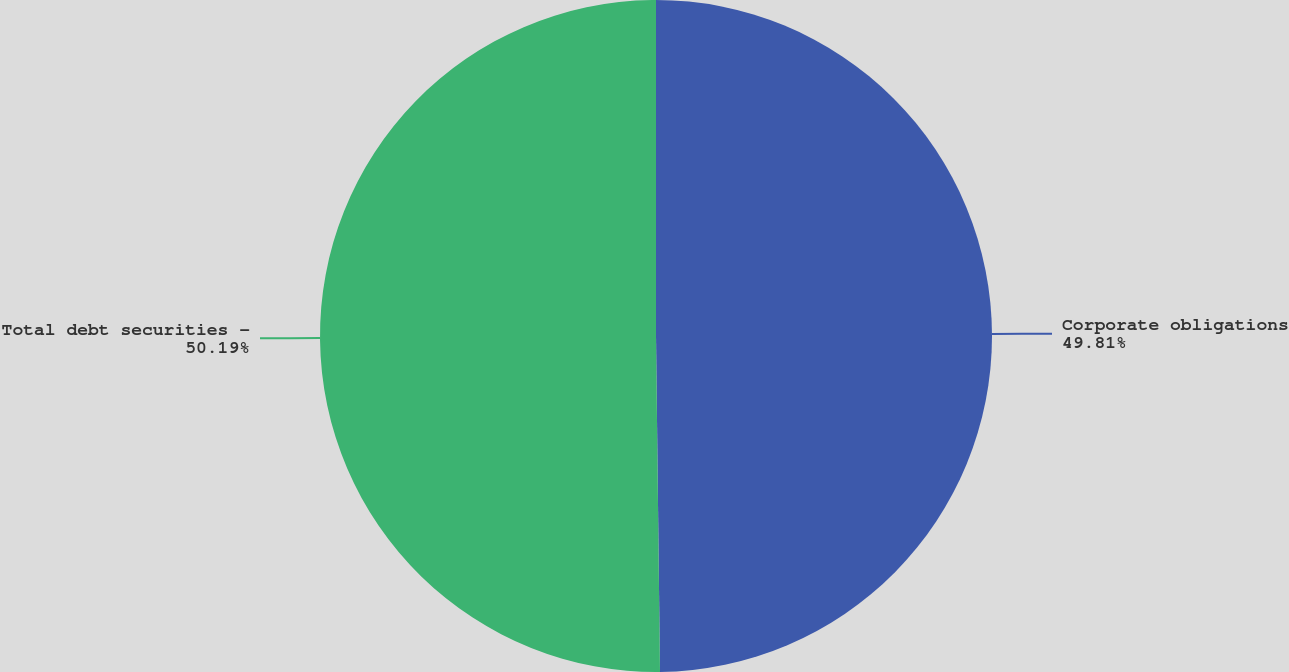Convert chart to OTSL. <chart><loc_0><loc_0><loc_500><loc_500><pie_chart><fcel>Corporate obligations<fcel>Total debt securities -<nl><fcel>49.81%<fcel>50.19%<nl></chart> 